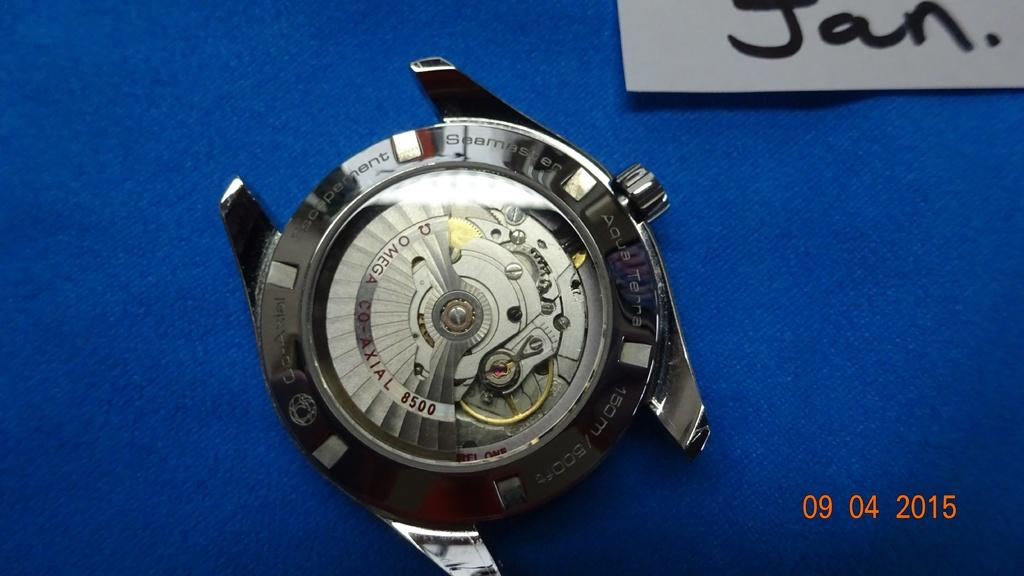<image>
Create a compact narrative representing the image presented. A picture taken 09 04  shows an Escapement Seamaster Aqua Terra. 